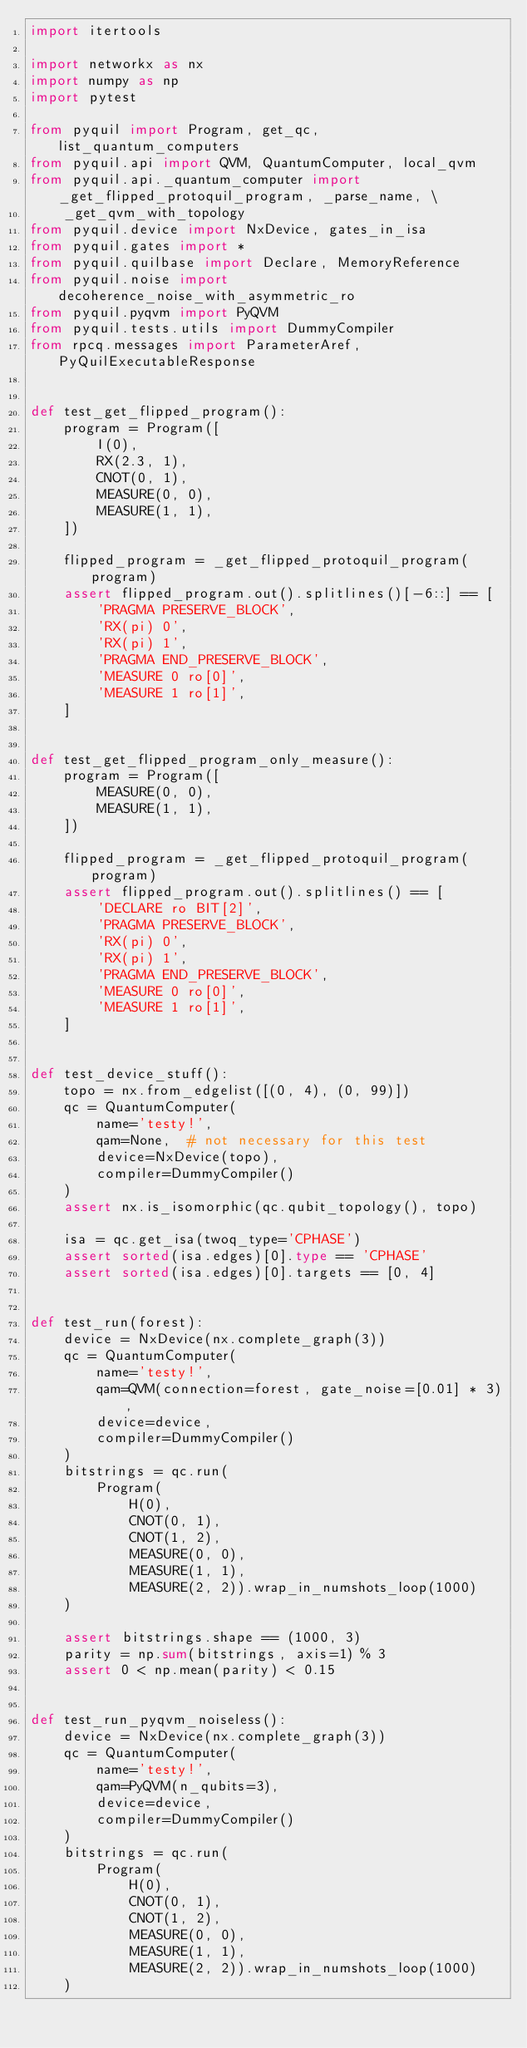Convert code to text. <code><loc_0><loc_0><loc_500><loc_500><_Python_>import itertools

import networkx as nx
import numpy as np
import pytest

from pyquil import Program, get_qc, list_quantum_computers
from pyquil.api import QVM, QuantumComputer, local_qvm
from pyquil.api._quantum_computer import _get_flipped_protoquil_program, _parse_name, \
    _get_qvm_with_topology
from pyquil.device import NxDevice, gates_in_isa
from pyquil.gates import *
from pyquil.quilbase import Declare, MemoryReference
from pyquil.noise import decoherence_noise_with_asymmetric_ro
from pyquil.pyqvm import PyQVM
from pyquil.tests.utils import DummyCompiler
from rpcq.messages import ParameterAref, PyQuilExecutableResponse


def test_get_flipped_program():
    program = Program([
        I(0),
        RX(2.3, 1),
        CNOT(0, 1),
        MEASURE(0, 0),
        MEASURE(1, 1),
    ])

    flipped_program = _get_flipped_protoquil_program(program)
    assert flipped_program.out().splitlines()[-6::] == [
        'PRAGMA PRESERVE_BLOCK',
        'RX(pi) 0',
        'RX(pi) 1',
        'PRAGMA END_PRESERVE_BLOCK',
        'MEASURE 0 ro[0]',
        'MEASURE 1 ro[1]',
    ]


def test_get_flipped_program_only_measure():
    program = Program([
        MEASURE(0, 0),
        MEASURE(1, 1),
    ])

    flipped_program = _get_flipped_protoquil_program(program)
    assert flipped_program.out().splitlines() == [
        'DECLARE ro BIT[2]',
        'PRAGMA PRESERVE_BLOCK',
        'RX(pi) 0',
        'RX(pi) 1',
        'PRAGMA END_PRESERVE_BLOCK',
        'MEASURE 0 ro[0]',
        'MEASURE 1 ro[1]',
    ]


def test_device_stuff():
    topo = nx.from_edgelist([(0, 4), (0, 99)])
    qc = QuantumComputer(
        name='testy!',
        qam=None,  # not necessary for this test
        device=NxDevice(topo),
        compiler=DummyCompiler()
    )
    assert nx.is_isomorphic(qc.qubit_topology(), topo)

    isa = qc.get_isa(twoq_type='CPHASE')
    assert sorted(isa.edges)[0].type == 'CPHASE'
    assert sorted(isa.edges)[0].targets == [0, 4]


def test_run(forest):
    device = NxDevice(nx.complete_graph(3))
    qc = QuantumComputer(
        name='testy!',
        qam=QVM(connection=forest, gate_noise=[0.01] * 3),
        device=device,
        compiler=DummyCompiler()
    )
    bitstrings = qc.run(
        Program(
            H(0),
            CNOT(0, 1),
            CNOT(1, 2),
            MEASURE(0, 0),
            MEASURE(1, 1),
            MEASURE(2, 2)).wrap_in_numshots_loop(1000)
    )

    assert bitstrings.shape == (1000, 3)
    parity = np.sum(bitstrings, axis=1) % 3
    assert 0 < np.mean(parity) < 0.15


def test_run_pyqvm_noiseless():
    device = NxDevice(nx.complete_graph(3))
    qc = QuantumComputer(
        name='testy!',
        qam=PyQVM(n_qubits=3),
        device=device,
        compiler=DummyCompiler()
    )
    bitstrings = qc.run(
        Program(
            H(0),
            CNOT(0, 1),
            CNOT(1, 2),
            MEASURE(0, 0),
            MEASURE(1, 1),
            MEASURE(2, 2)).wrap_in_numshots_loop(1000)
    )
</code> 